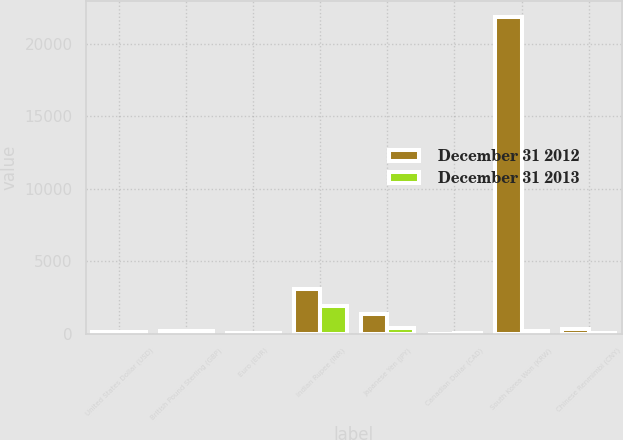Convert chart to OTSL. <chart><loc_0><loc_0><loc_500><loc_500><stacked_bar_chart><ecel><fcel>United States Dollar (USD)<fcel>British Pound Sterling (GBP)<fcel>Euro (EUR)<fcel>Indian Rupee (INR)<fcel>Japanese Yen (JPY)<fcel>Canadian Dollar (CAD)<fcel>South Korea Won (KRW)<fcel>Chinese Renmimbi (CNY)<nl><fcel>December 31 2012<fcel>98<fcel>170<fcel>32<fcel>3118<fcel>1357<fcel>14<fcel>21855<fcel>331<nl><fcel>December 31 2013<fcel>110<fcel>227<fcel>28<fcel>1943<fcel>384<fcel>59<fcel>170<fcel>45<nl></chart> 